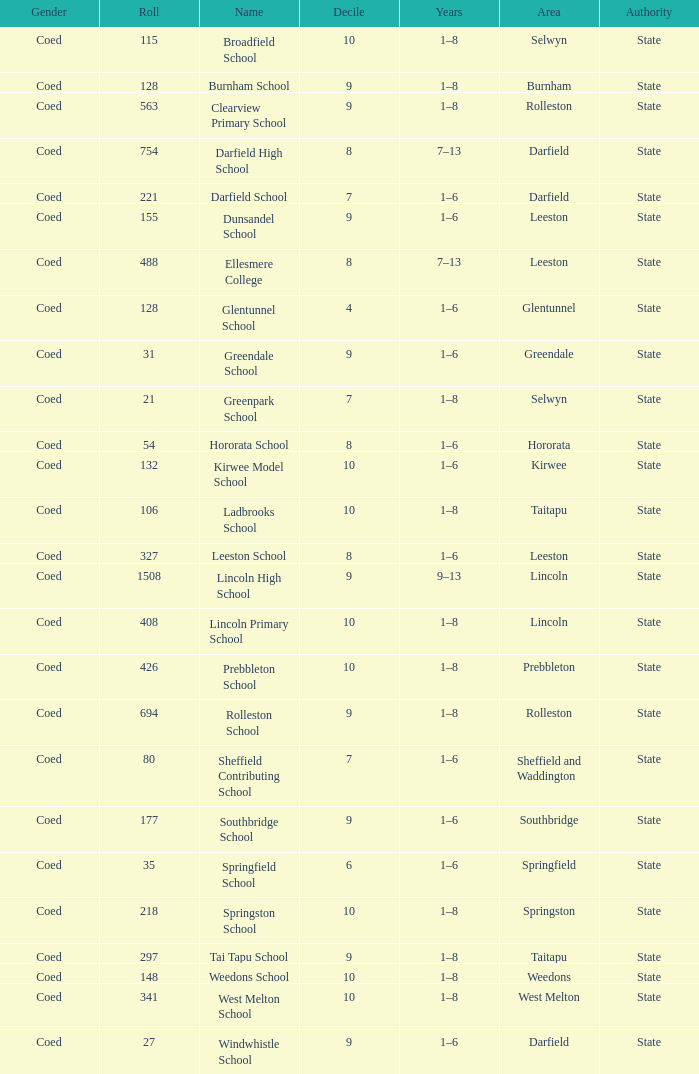Parse the table in full. {'header': ['Gender', 'Roll', 'Name', 'Decile', 'Years', 'Area', 'Authority'], 'rows': [['Coed', '115', 'Broadfield School', '10', '1–8', 'Selwyn', 'State'], ['Coed', '128', 'Burnham School', '9', '1–8', 'Burnham', 'State'], ['Coed', '563', 'Clearview Primary School', '9', '1–8', 'Rolleston', 'State'], ['Coed', '754', 'Darfield High School', '8', '7–13', 'Darfield', 'State'], ['Coed', '221', 'Darfield School', '7', '1–6', 'Darfield', 'State'], ['Coed', '155', 'Dunsandel School', '9', '1–6', 'Leeston', 'State'], ['Coed', '488', 'Ellesmere College', '8', '7–13', 'Leeston', 'State'], ['Coed', '128', 'Glentunnel School', '4', '1–6', 'Glentunnel', 'State'], ['Coed', '31', 'Greendale School', '9', '1–6', 'Greendale', 'State'], ['Coed', '21', 'Greenpark School', '7', '1–8', 'Selwyn', 'State'], ['Coed', '54', 'Hororata School', '8', '1–6', 'Hororata', 'State'], ['Coed', '132', 'Kirwee Model School', '10', '1–6', 'Kirwee', 'State'], ['Coed', '106', 'Ladbrooks School', '10', '1–8', 'Taitapu', 'State'], ['Coed', '327', 'Leeston School', '8', '1–6', 'Leeston', 'State'], ['Coed', '1508', 'Lincoln High School', '9', '9–13', 'Lincoln', 'State'], ['Coed', '408', 'Lincoln Primary School', '10', '1–8', 'Lincoln', 'State'], ['Coed', '426', 'Prebbleton School', '10', '1–8', 'Prebbleton', 'State'], ['Coed', '694', 'Rolleston School', '9', '1–8', 'Rolleston', 'State'], ['Coed', '80', 'Sheffield Contributing School', '7', '1–6', 'Sheffield and Waddington', 'State'], ['Coed', '177', 'Southbridge School', '9', '1–6', 'Southbridge', 'State'], ['Coed', '35', 'Springfield School', '6', '1–6', 'Springfield', 'State'], ['Coed', '218', 'Springston School', '10', '1–8', 'Springston', 'State'], ['Coed', '297', 'Tai Tapu School', '9', '1–8', 'Taitapu', 'State'], ['Coed', '148', 'Weedons School', '10', '1–8', 'Weedons', 'State'], ['Coed', '341', 'West Melton School', '10', '1–8', 'West Melton', 'State'], ['Coed', '27', 'Windwhistle School', '9', '1–6', 'Darfield', 'State']]} How many deciles have Years of 9–13? 1.0. 